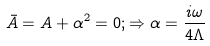Convert formula to latex. <formula><loc_0><loc_0><loc_500><loc_500>\bar { A } = A + \alpha ^ { 2 } = 0 ; \Rightarrow \alpha = \frac { i \omega } { 4 \Lambda }</formula> 